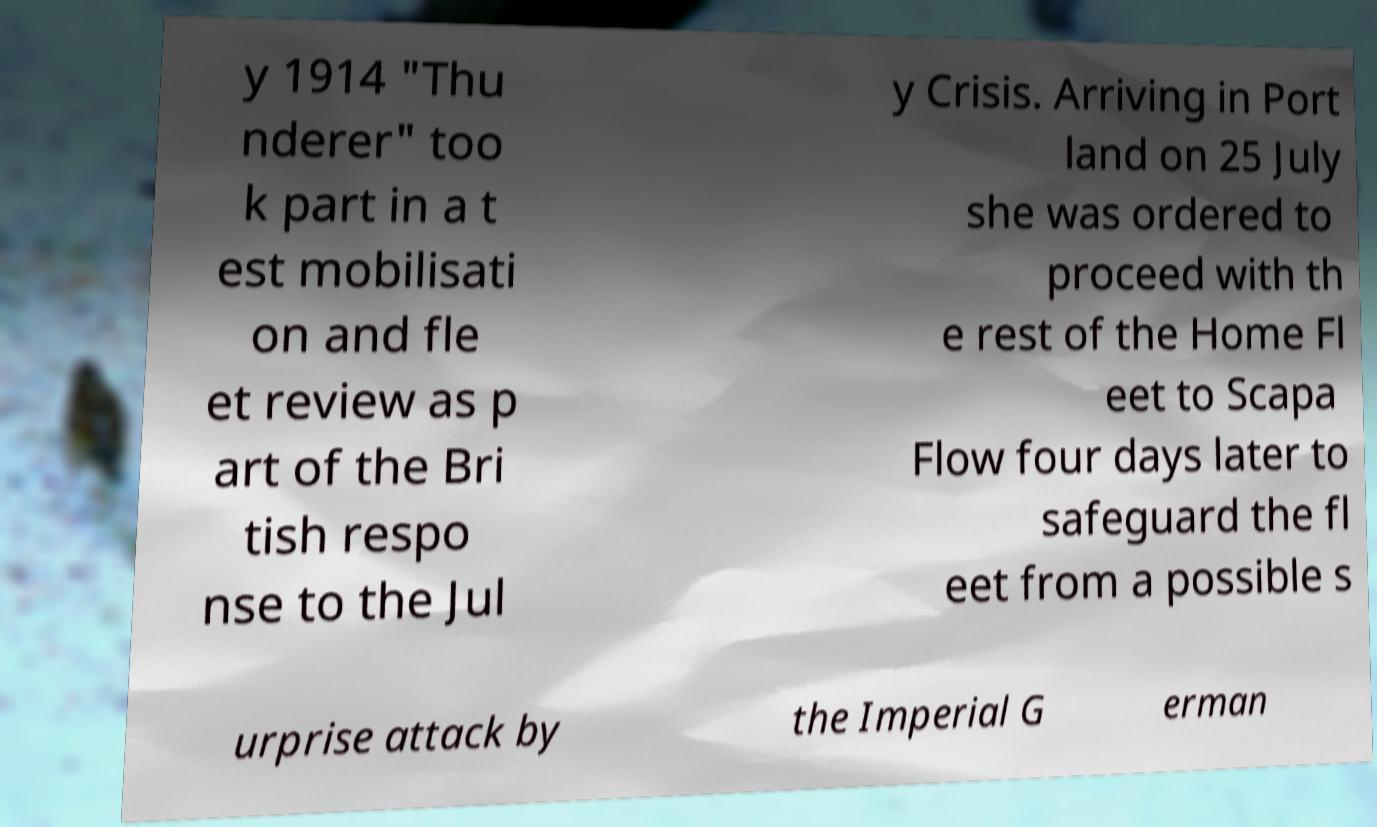What messages or text are displayed in this image? I need them in a readable, typed format. y 1914 "Thu nderer" too k part in a t est mobilisati on and fle et review as p art of the Bri tish respo nse to the Jul y Crisis. Arriving in Port land on 25 July she was ordered to proceed with th e rest of the Home Fl eet to Scapa Flow four days later to safeguard the fl eet from a possible s urprise attack by the Imperial G erman 